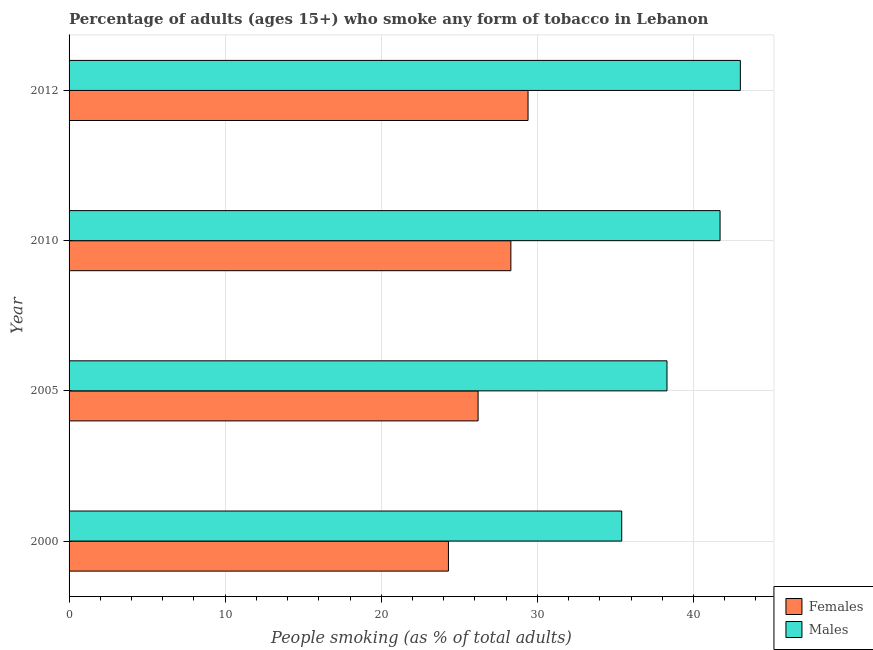Are the number of bars per tick equal to the number of legend labels?
Your answer should be compact. Yes. Are the number of bars on each tick of the Y-axis equal?
Ensure brevity in your answer.  Yes. How many bars are there on the 1st tick from the top?
Your answer should be compact. 2. How many bars are there on the 2nd tick from the bottom?
Offer a terse response. 2. What is the percentage of males who smoke in 2000?
Your answer should be very brief. 35.4. Across all years, what is the maximum percentage of females who smoke?
Offer a terse response. 29.4. Across all years, what is the minimum percentage of males who smoke?
Your answer should be very brief. 35.4. In which year was the percentage of females who smoke maximum?
Offer a terse response. 2012. In which year was the percentage of females who smoke minimum?
Keep it short and to the point. 2000. What is the total percentage of males who smoke in the graph?
Your answer should be compact. 158.4. What is the difference between the percentage of males who smoke in 2000 and that in 2005?
Provide a succinct answer. -2.9. What is the difference between the percentage of males who smoke in 2010 and the percentage of females who smoke in 2012?
Provide a short and direct response. 12.3. What is the average percentage of females who smoke per year?
Provide a succinct answer. 27.05. In the year 2010, what is the difference between the percentage of males who smoke and percentage of females who smoke?
Your response must be concise. 13.4. In how many years, is the percentage of males who smoke greater than 36 %?
Provide a short and direct response. 3. What is the ratio of the percentage of females who smoke in 2010 to that in 2012?
Your answer should be compact. 0.96. Is the percentage of females who smoke in 2000 less than that in 2010?
Your answer should be very brief. Yes. What is the difference between the highest and the lowest percentage of females who smoke?
Keep it short and to the point. 5.1. What does the 1st bar from the top in 2012 represents?
Make the answer very short. Males. What does the 2nd bar from the bottom in 2012 represents?
Provide a succinct answer. Males. Are all the bars in the graph horizontal?
Offer a terse response. Yes. How many legend labels are there?
Ensure brevity in your answer.  2. What is the title of the graph?
Make the answer very short. Percentage of adults (ages 15+) who smoke any form of tobacco in Lebanon. Does "Borrowers" appear as one of the legend labels in the graph?
Your answer should be very brief. No. What is the label or title of the X-axis?
Your response must be concise. People smoking (as % of total adults). What is the label or title of the Y-axis?
Provide a short and direct response. Year. What is the People smoking (as % of total adults) of Females in 2000?
Offer a very short reply. 24.3. What is the People smoking (as % of total adults) in Males in 2000?
Your answer should be compact. 35.4. What is the People smoking (as % of total adults) in Females in 2005?
Offer a terse response. 26.2. What is the People smoking (as % of total adults) in Males in 2005?
Your answer should be compact. 38.3. What is the People smoking (as % of total adults) of Females in 2010?
Ensure brevity in your answer.  28.3. What is the People smoking (as % of total adults) of Males in 2010?
Your answer should be very brief. 41.7. What is the People smoking (as % of total adults) in Females in 2012?
Offer a terse response. 29.4. Across all years, what is the maximum People smoking (as % of total adults) of Females?
Keep it short and to the point. 29.4. Across all years, what is the minimum People smoking (as % of total adults) of Females?
Offer a terse response. 24.3. Across all years, what is the minimum People smoking (as % of total adults) of Males?
Ensure brevity in your answer.  35.4. What is the total People smoking (as % of total adults) in Females in the graph?
Make the answer very short. 108.2. What is the total People smoking (as % of total adults) in Males in the graph?
Give a very brief answer. 158.4. What is the difference between the People smoking (as % of total adults) in Females in 2000 and that in 2010?
Offer a very short reply. -4. What is the difference between the People smoking (as % of total adults) in Males in 2000 and that in 2010?
Offer a very short reply. -6.3. What is the difference between the People smoking (as % of total adults) in Males in 2000 and that in 2012?
Offer a terse response. -7.6. What is the difference between the People smoking (as % of total adults) of Females in 2005 and that in 2010?
Make the answer very short. -2.1. What is the difference between the People smoking (as % of total adults) in Males in 2005 and that in 2010?
Make the answer very short. -3.4. What is the difference between the People smoking (as % of total adults) in Females in 2005 and that in 2012?
Give a very brief answer. -3.2. What is the difference between the People smoking (as % of total adults) in Males in 2010 and that in 2012?
Offer a very short reply. -1.3. What is the difference between the People smoking (as % of total adults) of Females in 2000 and the People smoking (as % of total adults) of Males in 2005?
Offer a terse response. -14. What is the difference between the People smoking (as % of total adults) of Females in 2000 and the People smoking (as % of total adults) of Males in 2010?
Ensure brevity in your answer.  -17.4. What is the difference between the People smoking (as % of total adults) of Females in 2000 and the People smoking (as % of total adults) of Males in 2012?
Your answer should be very brief. -18.7. What is the difference between the People smoking (as % of total adults) of Females in 2005 and the People smoking (as % of total adults) of Males in 2010?
Keep it short and to the point. -15.5. What is the difference between the People smoking (as % of total adults) in Females in 2005 and the People smoking (as % of total adults) in Males in 2012?
Make the answer very short. -16.8. What is the difference between the People smoking (as % of total adults) in Females in 2010 and the People smoking (as % of total adults) in Males in 2012?
Your answer should be very brief. -14.7. What is the average People smoking (as % of total adults) of Females per year?
Your answer should be very brief. 27.05. What is the average People smoking (as % of total adults) of Males per year?
Your response must be concise. 39.6. In the year 2005, what is the difference between the People smoking (as % of total adults) in Females and People smoking (as % of total adults) in Males?
Your answer should be very brief. -12.1. In the year 2010, what is the difference between the People smoking (as % of total adults) of Females and People smoking (as % of total adults) of Males?
Make the answer very short. -13.4. In the year 2012, what is the difference between the People smoking (as % of total adults) of Females and People smoking (as % of total adults) of Males?
Your response must be concise. -13.6. What is the ratio of the People smoking (as % of total adults) of Females in 2000 to that in 2005?
Your response must be concise. 0.93. What is the ratio of the People smoking (as % of total adults) of Males in 2000 to that in 2005?
Offer a terse response. 0.92. What is the ratio of the People smoking (as % of total adults) in Females in 2000 to that in 2010?
Your response must be concise. 0.86. What is the ratio of the People smoking (as % of total adults) in Males in 2000 to that in 2010?
Offer a very short reply. 0.85. What is the ratio of the People smoking (as % of total adults) in Females in 2000 to that in 2012?
Offer a very short reply. 0.83. What is the ratio of the People smoking (as % of total adults) in Males in 2000 to that in 2012?
Provide a succinct answer. 0.82. What is the ratio of the People smoking (as % of total adults) in Females in 2005 to that in 2010?
Your response must be concise. 0.93. What is the ratio of the People smoking (as % of total adults) in Males in 2005 to that in 2010?
Your answer should be compact. 0.92. What is the ratio of the People smoking (as % of total adults) of Females in 2005 to that in 2012?
Ensure brevity in your answer.  0.89. What is the ratio of the People smoking (as % of total adults) in Males in 2005 to that in 2012?
Offer a terse response. 0.89. What is the ratio of the People smoking (as % of total adults) of Females in 2010 to that in 2012?
Offer a terse response. 0.96. What is the ratio of the People smoking (as % of total adults) of Males in 2010 to that in 2012?
Give a very brief answer. 0.97. What is the difference between the highest and the second highest People smoking (as % of total adults) in Males?
Ensure brevity in your answer.  1.3. 